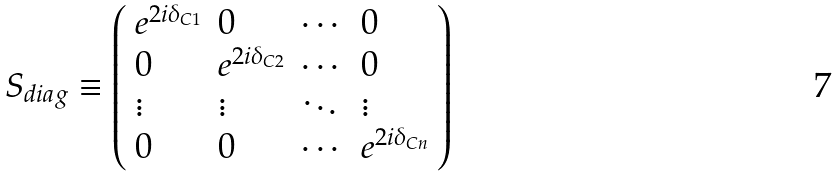<formula> <loc_0><loc_0><loc_500><loc_500>S _ { d i a g } \equiv \left ( \begin{array} { l l l l } e ^ { 2 i \delta _ { C 1 } } & 0 & \cdots & 0 \\ 0 & e ^ { 2 i \delta _ { C 2 } } & \cdots & 0 \\ \vdots & \vdots & \ddots & \vdots \\ 0 & 0 & \cdots & e ^ { 2 i \delta _ { C n } } \end{array} \right )</formula> 